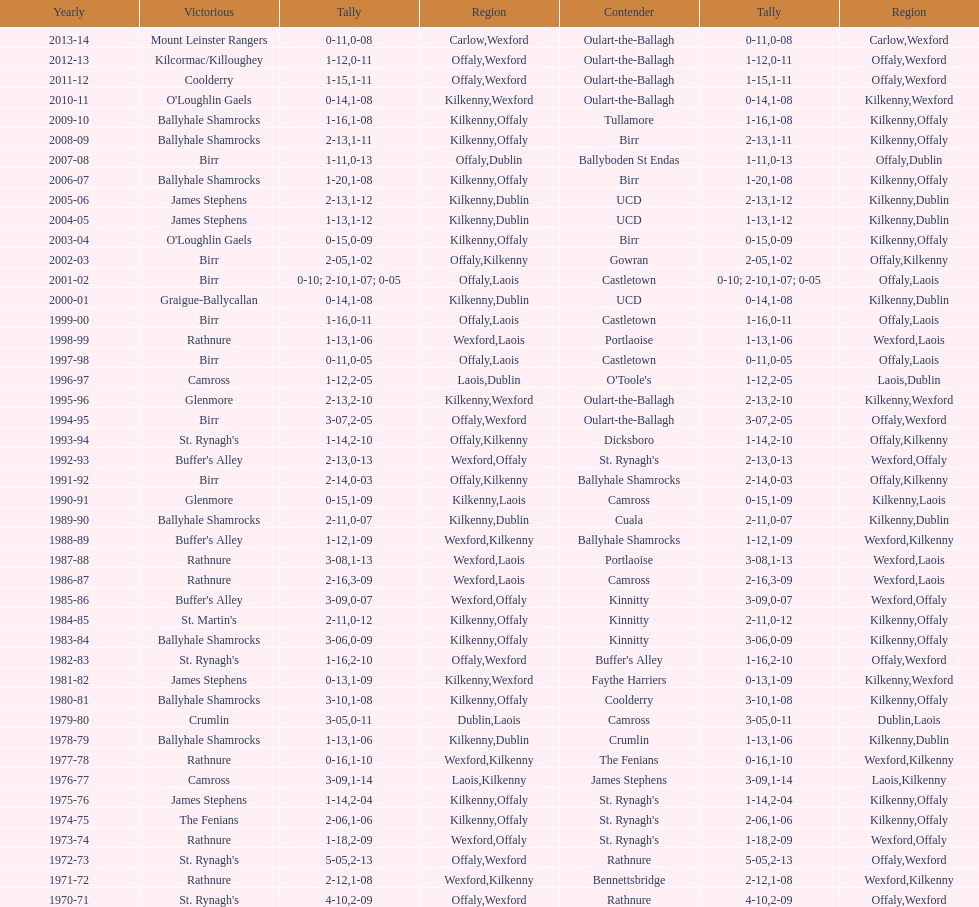Which country had the most wins? Kilkenny. I'm looking to parse the entire table for insights. Could you assist me with that? {'header': ['Yearly', 'Victorious', 'Tally', 'Region', 'Contender', 'Tally', 'Region'], 'rows': [['2013-14', 'Mount Leinster Rangers', '0-11', 'Carlow', 'Oulart-the-Ballagh', '0-08', 'Wexford'], ['2012-13', 'Kilcormac/Killoughey', '1-12', 'Offaly', 'Oulart-the-Ballagh', '0-11', 'Wexford'], ['2011-12', 'Coolderry', '1-15', 'Offaly', 'Oulart-the-Ballagh', '1-11', 'Wexford'], ['2010-11', "O'Loughlin Gaels", '0-14', 'Kilkenny', 'Oulart-the-Ballagh', '1-08', 'Wexford'], ['2009-10', 'Ballyhale Shamrocks', '1-16', 'Kilkenny', 'Tullamore', '1-08', 'Offaly'], ['2008-09', 'Ballyhale Shamrocks', '2-13', 'Kilkenny', 'Birr', '1-11', 'Offaly'], ['2007-08', 'Birr', '1-11', 'Offaly', 'Ballyboden St Endas', '0-13', 'Dublin'], ['2006-07', 'Ballyhale Shamrocks', '1-20', 'Kilkenny', 'Birr', '1-08', 'Offaly'], ['2005-06', 'James Stephens', '2-13', 'Kilkenny', 'UCD', '1-12', 'Dublin'], ['2004-05', 'James Stephens', '1-13', 'Kilkenny', 'UCD', '1-12', 'Dublin'], ['2003-04', "O'Loughlin Gaels", '0-15', 'Kilkenny', 'Birr', '0-09', 'Offaly'], ['2002-03', 'Birr', '2-05', 'Offaly', 'Gowran', '1-02', 'Kilkenny'], ['2001-02', 'Birr', '0-10; 2-10', 'Offaly', 'Castletown', '1-07; 0-05', 'Laois'], ['2000-01', 'Graigue-Ballycallan', '0-14', 'Kilkenny', 'UCD', '1-08', 'Dublin'], ['1999-00', 'Birr', '1-16', 'Offaly', 'Castletown', '0-11', 'Laois'], ['1998-99', 'Rathnure', '1-13', 'Wexford', 'Portlaoise', '1-06', 'Laois'], ['1997-98', 'Birr', '0-11', 'Offaly', 'Castletown', '0-05', 'Laois'], ['1996-97', 'Camross', '1-12', 'Laois', "O'Toole's", '2-05', 'Dublin'], ['1995-96', 'Glenmore', '2-13', 'Kilkenny', 'Oulart-the-Ballagh', '2-10', 'Wexford'], ['1994-95', 'Birr', '3-07', 'Offaly', 'Oulart-the-Ballagh', '2-05', 'Wexford'], ['1993-94', "St. Rynagh's", '1-14', 'Offaly', 'Dicksboro', '2-10', 'Kilkenny'], ['1992-93', "Buffer's Alley", '2-13', 'Wexford', "St. Rynagh's", '0-13', 'Offaly'], ['1991-92', 'Birr', '2-14', 'Offaly', 'Ballyhale Shamrocks', '0-03', 'Kilkenny'], ['1990-91', 'Glenmore', '0-15', 'Kilkenny', 'Camross', '1-09', 'Laois'], ['1989-90', 'Ballyhale Shamrocks', '2-11', 'Kilkenny', 'Cuala', '0-07', 'Dublin'], ['1988-89', "Buffer's Alley", '1-12', 'Wexford', 'Ballyhale Shamrocks', '1-09', 'Kilkenny'], ['1987-88', 'Rathnure', '3-08', 'Wexford', 'Portlaoise', '1-13', 'Laois'], ['1986-87', 'Rathnure', '2-16', 'Wexford', 'Camross', '3-09', 'Laois'], ['1985-86', "Buffer's Alley", '3-09', 'Wexford', 'Kinnitty', '0-07', 'Offaly'], ['1984-85', "St. Martin's", '2-11', 'Kilkenny', 'Kinnitty', '0-12', 'Offaly'], ['1983-84', 'Ballyhale Shamrocks', '3-06', 'Kilkenny', 'Kinnitty', '0-09', 'Offaly'], ['1982-83', "St. Rynagh's", '1-16', 'Offaly', "Buffer's Alley", '2-10', 'Wexford'], ['1981-82', 'James Stephens', '0-13', 'Kilkenny', 'Faythe Harriers', '1-09', 'Wexford'], ['1980-81', 'Ballyhale Shamrocks', '3-10', 'Kilkenny', 'Coolderry', '1-08', 'Offaly'], ['1979-80', 'Crumlin', '3-05', 'Dublin', 'Camross', '0-11', 'Laois'], ['1978-79', 'Ballyhale Shamrocks', '1-13', 'Kilkenny', 'Crumlin', '1-06', 'Dublin'], ['1977-78', 'Rathnure', '0-16', 'Wexford', 'The Fenians', '1-10', 'Kilkenny'], ['1976-77', 'Camross', '3-09', 'Laois', 'James Stephens', '1-14', 'Kilkenny'], ['1975-76', 'James Stephens', '1-14', 'Kilkenny', "St. Rynagh's", '2-04', 'Offaly'], ['1974-75', 'The Fenians', '2-06', 'Kilkenny', "St. Rynagh's", '1-06', 'Offaly'], ['1973-74', 'Rathnure', '1-18', 'Wexford', "St. Rynagh's", '2-09', 'Offaly'], ['1972-73', "St. Rynagh's", '5-05', 'Offaly', 'Rathnure', '2-13', 'Wexford'], ['1971-72', 'Rathnure', '2-12', 'Wexford', 'Bennettsbridge', '1-08', 'Kilkenny'], ['1970-71', "St. Rynagh's", '4-10', 'Offaly', 'Rathnure', '2-09', 'Wexford']]} 